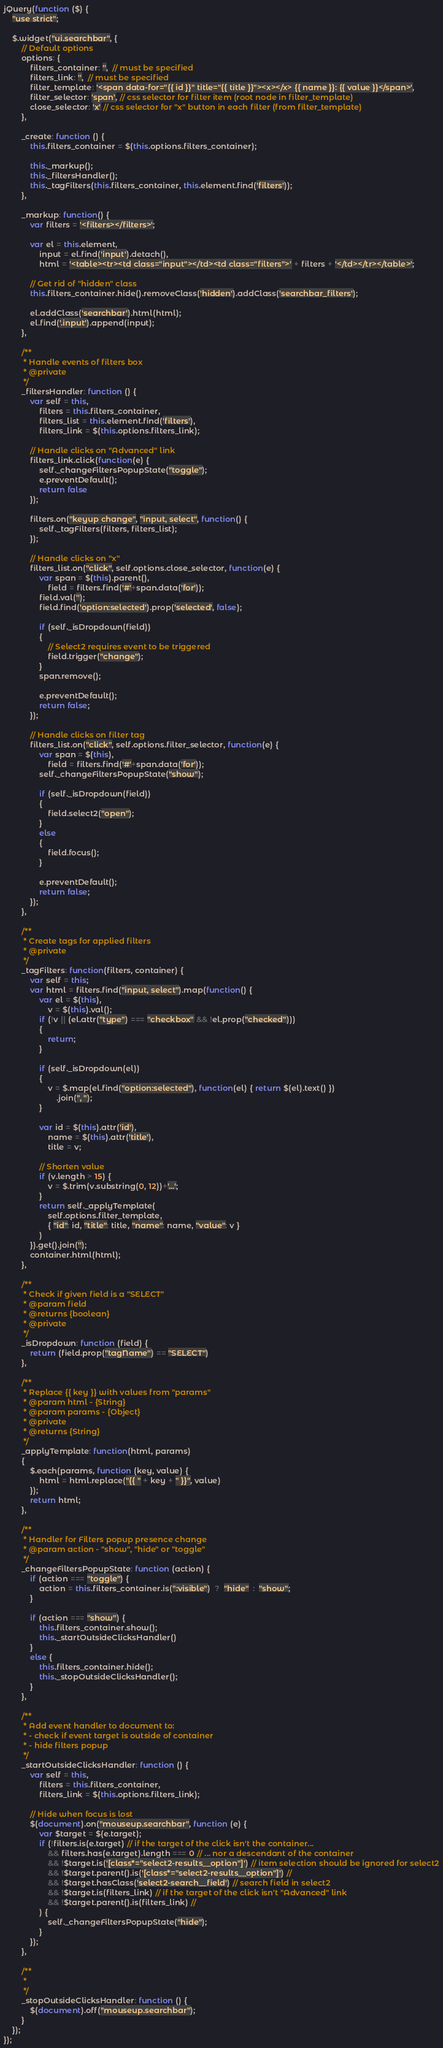<code> <loc_0><loc_0><loc_500><loc_500><_JavaScript_>jQuery(function ($) {
    "use strict";

    $.widget("ui.searchbar", {
        // Default options
        options: {
            filters_container: '',  // must be specified
            filters_link: '',  // must be specified
            filter_template: '<span data-for="{{ id }}" title="{{ title }}"><x></x> {{ name }}: {{ value }}</span>',
            filter_selector: 'span', // css selector for filter item (root node in filter_template)
            close_selector: 'x' // css selector for "x" button in each filter (from filter_template)
        },

        _create: function () {
            this.filters_container = $(this.options.filters_container);

            this._markup();
            this._filtersHandler();
            this._tagFilters(this.filters_container, this.element.find('filters'));
        },

        _markup: function() {
            var filters = '<filters></filters>';

            var el = this.element,
                input = el.find('input').detach(),
                html = '<table><tr><td class="input"></td><td class="filters">' + filters + '</td></tr></table>';

            // Get rid of "hidden" class
            this.filters_container.hide().removeClass('hidden').addClass('searchbar_filters');

            el.addClass('searchbar').html(html);
            el.find('.input').append(input);
        },

        /**
         * Handle events of filters box
         * @private
         */
        _filtersHandler: function () {
            var self = this,
                filters = this.filters_container,
                filters_list = this.element.find('filters'),
                filters_link = $(this.options.filters_link);

            // Handle clicks on "Advanced" link
            filters_link.click(function(e) {
                self._changeFiltersPopupState("toggle");
                e.preventDefault();
                return false
            });

            filters.on("keyup change", "input, select", function() {
                self._tagFilters(filters, filters_list);
            });

            // Handle clicks on "x"
            filters_list.on("click", self.options.close_selector, function(e) {
                var span = $(this).parent(),
                    field = filters.find('#'+span.data('for'));
                field.val('');
                field.find('option:selected').prop('selected', false);

                if (self._isDropdown(field))
                {
                    // Select2 requires event to be triggered
                    field.trigger("change");
                }
                span.remove();

                e.preventDefault();
                return false;
            });

            // Handle clicks on filter tag
            filters_list.on("click", self.options.filter_selector, function(e) {
                var span = $(this),
                    field = filters.find('#'+span.data('for'));
                self._changeFiltersPopupState("show");

                if (self._isDropdown(field))
                {
                    field.select2("open");
                }
                else
                {
                    field.focus();
                }

                e.preventDefault();
                return false;
            });
        },

        /**
         * Create tags for applied filters
         * @private
         */
        _tagFilters: function(filters, container) {
            var self = this;
            var html = filters.find("input, select").map(function() {
                var el = $(this),
                    v = $(this).val();
                if (!v || (el.attr("type") === "checkbox" && !el.prop("checked")))
                {
                    return;
                }

                if (self._isDropdown(el))
                {
                    v = $.map(el.find("option:selected"), function(el) { return $(el).text() })
                        .join(", ");
                }

                var id = $(this).attr('id'),
                    name = $(this).attr('title'),
                    title = v;

                // Shorten value
                if (v.length > 15) {
                    v = $.trim(v.substring(0, 12))+'...';
                }
                return self._applyTemplate(
                    self.options.filter_template,
                    { "id": id, "title": title, "name": name, "value": v }
                )
            }).get().join('');
            container.html(html);
        },

        /**
         * Check if given field is a "SELECT"
         * @param field
         * @returns {boolean}
         * @private
         */
        _isDropdown: function (field) {
            return (field.prop("tagName") == "SELECT")
        },

        /**
         * Replace {{ key }} with values from "params"
         * @param html - {String}
         * @param params - {Object}
         * @private
         * @returns {String}
         */
        _applyTemplate: function(html, params)
        {
            $.each(params, function (key, value) {
                html = html.replace("{{ " + key + " }}", value)
            });
            return html;
        },

        /**
         * Handler for Filters popup presence change
         * @param action - "show", "hide" or "toggle"
         */
        _changeFiltersPopupState: function (action) {
            if (action === "toggle") {
                action = this.filters_container.is(":visible")  ?  "hide"  :  "show";
            }

            if (action === "show") {
                this.filters_container.show();
                this._startOutsideClicksHandler()
            }
            else {
                this.filters_container.hide();
                this._stopOutsideClicksHandler();
            }
        },

        /**
         * Add event handler to document to:
         * - check if event target is outside of container
         * - hide filters popup
         */
        _startOutsideClicksHandler: function () {
            var self = this,
                filters = this.filters_container,
                filters_link = $(this.options.filters_link);

            // Hide when focus is lost
            $(document).on("mouseup.searchbar", function (e) {
                var $target = $(e.target);
                if (!filters.is(e.target) // if the target of the click isn't the container...
                    && filters.has(e.target).length === 0 // ... nor a descendant of the container
                    && !$target.is('[class*="select2-results__option"]') // item selection should be ignored for select2
                    && !$target.parent().is('[class*="select2-results__option"]') //
                    && !$target.hasClass('select2-search__field') // search field in select2
                    && !$target.is(filters_link) // if the target of the click isn't "Advanced" link
                    && !$target.parent().is(filters_link) //
                ) {
                    self._changeFiltersPopupState("hide");
                }
            });
        },

        /**
         *
         */
        _stopOutsideClicksHandler: function () {
            $(document).off("mouseup.searchbar");
        }
    });
});
</code> 